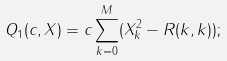<formula> <loc_0><loc_0><loc_500><loc_500>Q _ { 1 } ( c , X ) = c \sum _ { k = 0 } ^ { M } ( X ^ { 2 } _ { k } - R ( k , k ) ) ;</formula> 